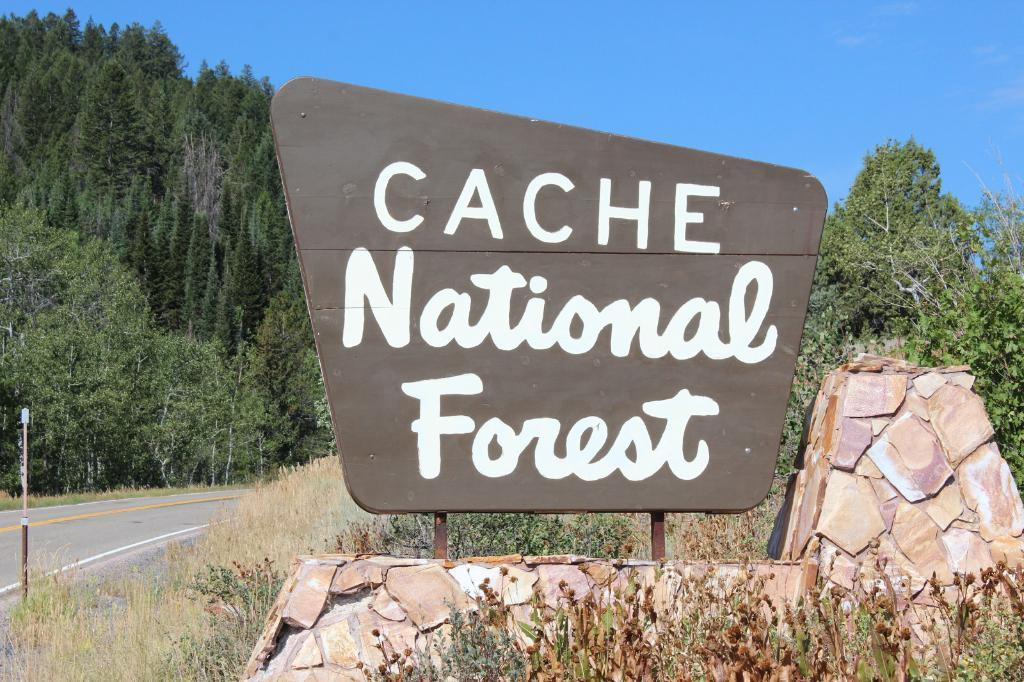What is the main object in the image? There is a board in the image. What other structures or objects can be seen in the image? There is a fence, grass, a pole, trees, and the sky visible in the image. What type of terrain is depicted in the image? The image features grass, which suggests a natural or outdoor setting. Can you tell if the image was taken during the day or night? The image was likely taken during the day, as the sky is visible. What type of sign can be seen in the image? There is no sign present in the image. 